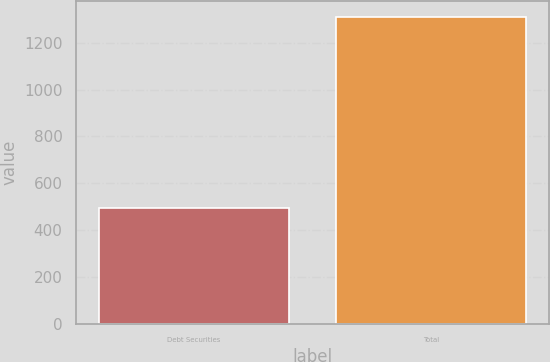Convert chart to OTSL. <chart><loc_0><loc_0><loc_500><loc_500><bar_chart><fcel>Debt Securities<fcel>Total<nl><fcel>493.8<fcel>1312.1<nl></chart> 